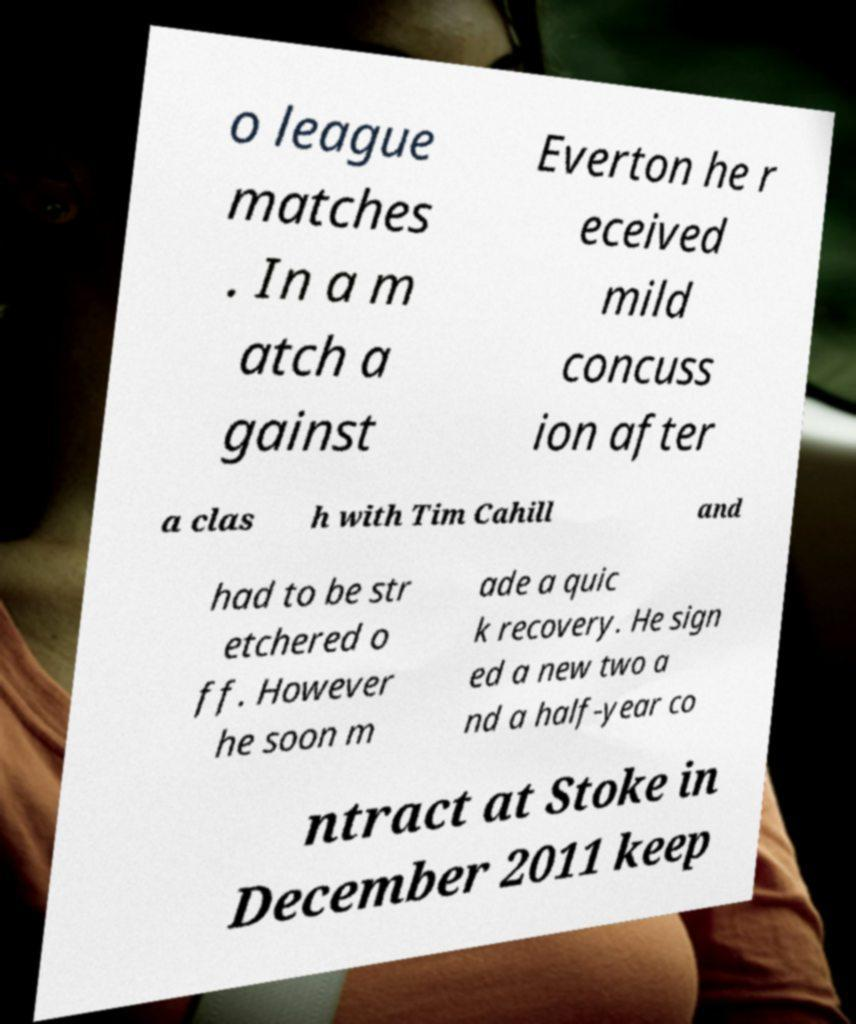Please read and relay the text visible in this image. What does it say? o league matches . In a m atch a gainst Everton he r eceived mild concuss ion after a clas h with Tim Cahill and had to be str etchered o ff. However he soon m ade a quic k recovery. He sign ed a new two a nd a half-year co ntract at Stoke in December 2011 keep 